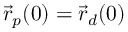<formula> <loc_0><loc_0><loc_500><loc_500>\vec { r } _ { p } ( 0 ) = \vec { r } _ { d } ( 0 )</formula> 